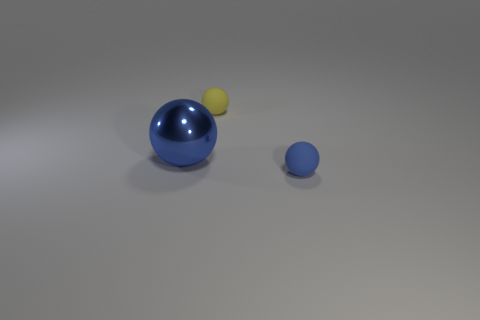Add 1 large gray metal blocks. How many objects exist? 4 Add 2 yellow rubber objects. How many yellow rubber objects exist? 3 Subtract 2 blue balls. How many objects are left? 1 Subtract all tiny blue rubber spheres. Subtract all yellow things. How many objects are left? 1 Add 1 yellow matte spheres. How many yellow matte spheres are left? 2 